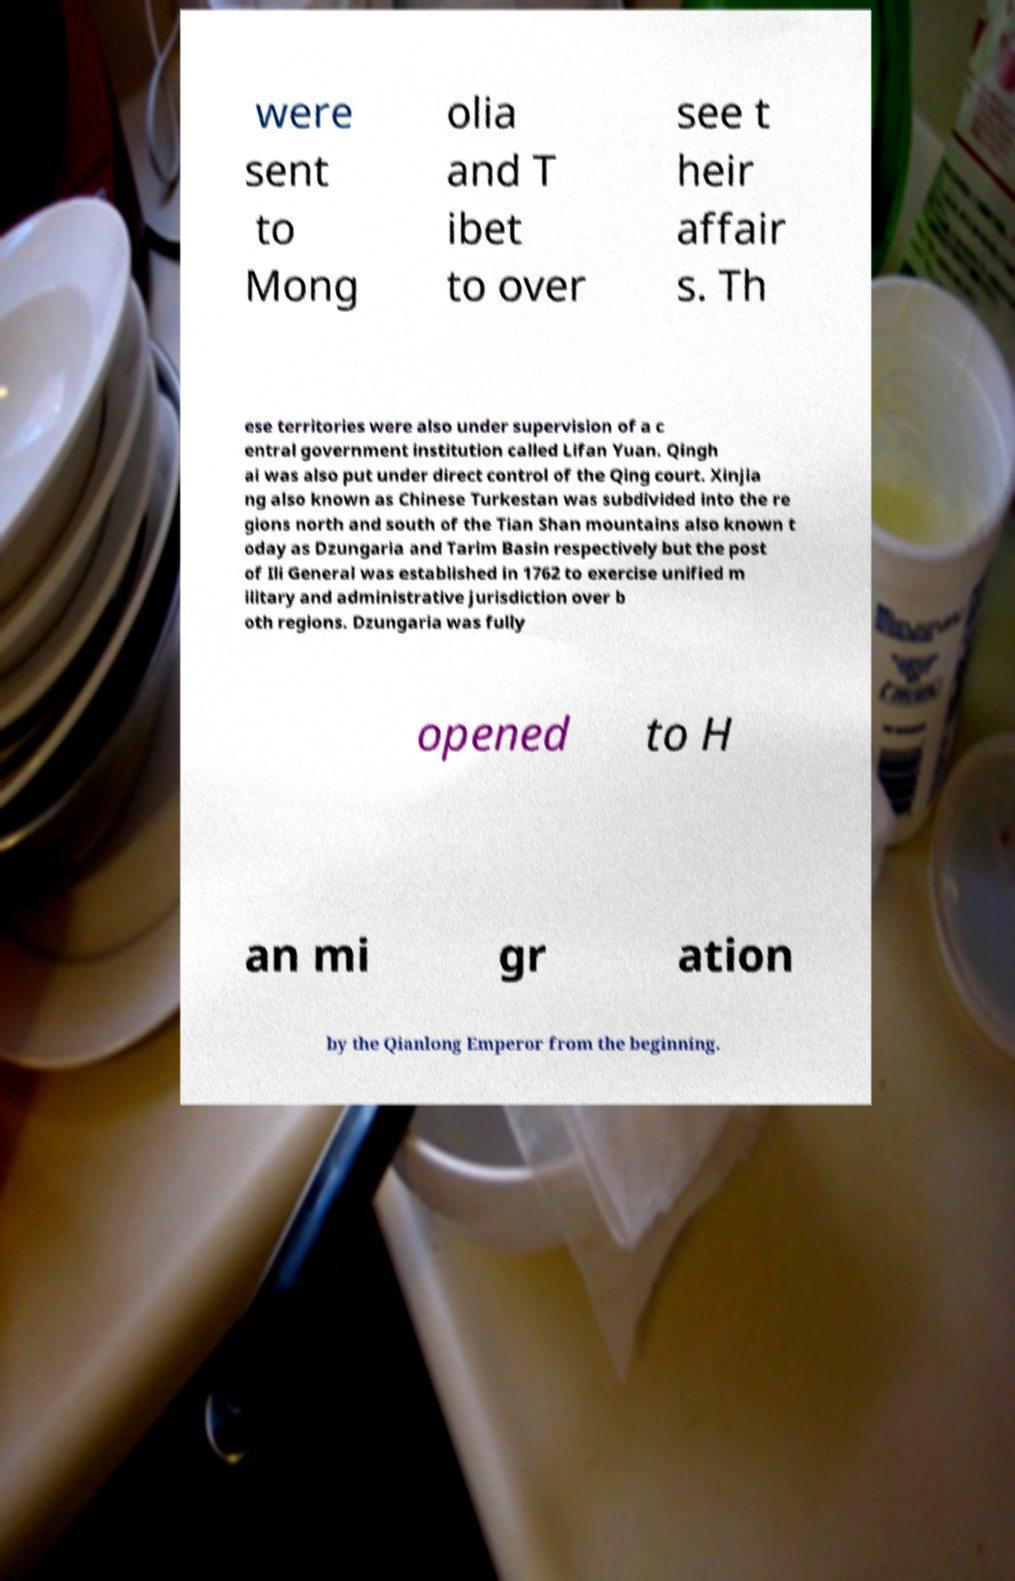For documentation purposes, I need the text within this image transcribed. Could you provide that? were sent to Mong olia and T ibet to over see t heir affair s. Th ese territories were also under supervision of a c entral government institution called Lifan Yuan. Qingh ai was also put under direct control of the Qing court. Xinjia ng also known as Chinese Turkestan was subdivided into the re gions north and south of the Tian Shan mountains also known t oday as Dzungaria and Tarim Basin respectively but the post of Ili General was established in 1762 to exercise unified m ilitary and administrative jurisdiction over b oth regions. Dzungaria was fully opened to H an mi gr ation by the Qianlong Emperor from the beginning. 